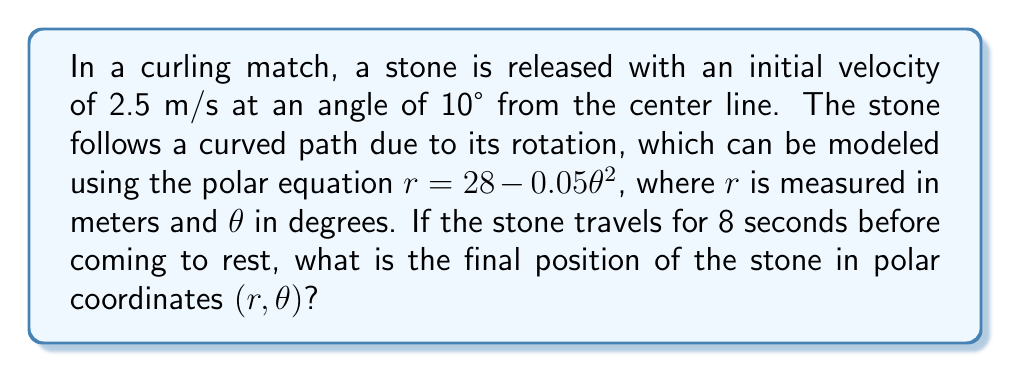Show me your answer to this math problem. Let's approach this step-by-step:

1) First, we need to determine the angle $\theta$ that the stone travels in 8 seconds. We can use the initial velocity and time to calculate the arc length:

   Arc length $s = v \cdot t = 2.5 \text{ m/s} \cdot 8 \text{ s} = 20 \text{ m}$

2) The arc length in polar coordinates is given by:
   
   $s = \int_0^\theta \sqrt{r^2 + (\frac{dr}{d\theta})^2} d\theta$

3) However, this integral is complex to solve directly. Given the context of curling, where the stone's path is relatively straight, we can approximate $\theta$ using the arc length formula for a circle:

   $\theta \approx \frac{s}{r_{avg}} \cdot \frac{180°}{\pi}$

4) We need an average radius. Let's use the initial radius from our equation:
   
   $r_{initial} = 28 - 0.05 \cdot 0^2 = 28 \text{ m}$

5) Now we can estimate $\theta$:

   $\theta \approx \frac{20}{28} \cdot \frac{180°}{\pi} \approx 40.8°$

6) With this $\theta$, we can calculate the final $r$ using the given equation:

   $r = 28 - 0.05\theta^2 = 28 - 0.05 \cdot (40.8)^2 \approx 27.17 \text{ m}$

7) Therefore, the final position of the stone in polar coordinates is approximately $(27.17, 40.8)$.
Answer: $(27.17 \text{ m}, 40.8°)$ 